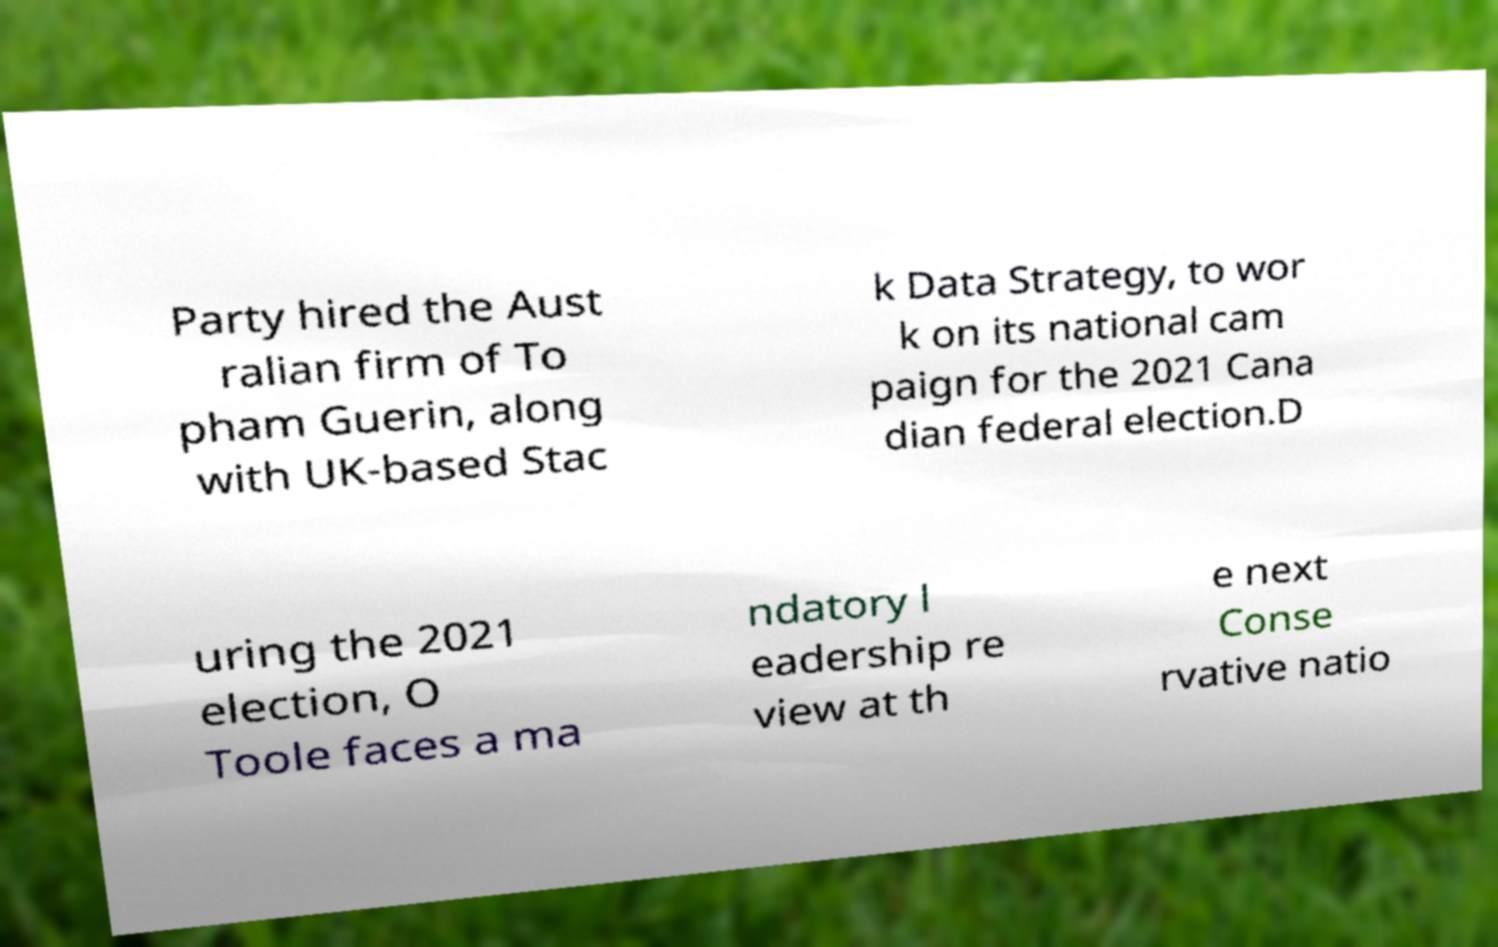Could you assist in decoding the text presented in this image and type it out clearly? Party hired the Aust ralian firm of To pham Guerin, along with UK-based Stac k Data Strategy, to wor k on its national cam paign for the 2021 Cana dian federal election.D uring the 2021 election, O Toole faces a ma ndatory l eadership re view at th e next Conse rvative natio 